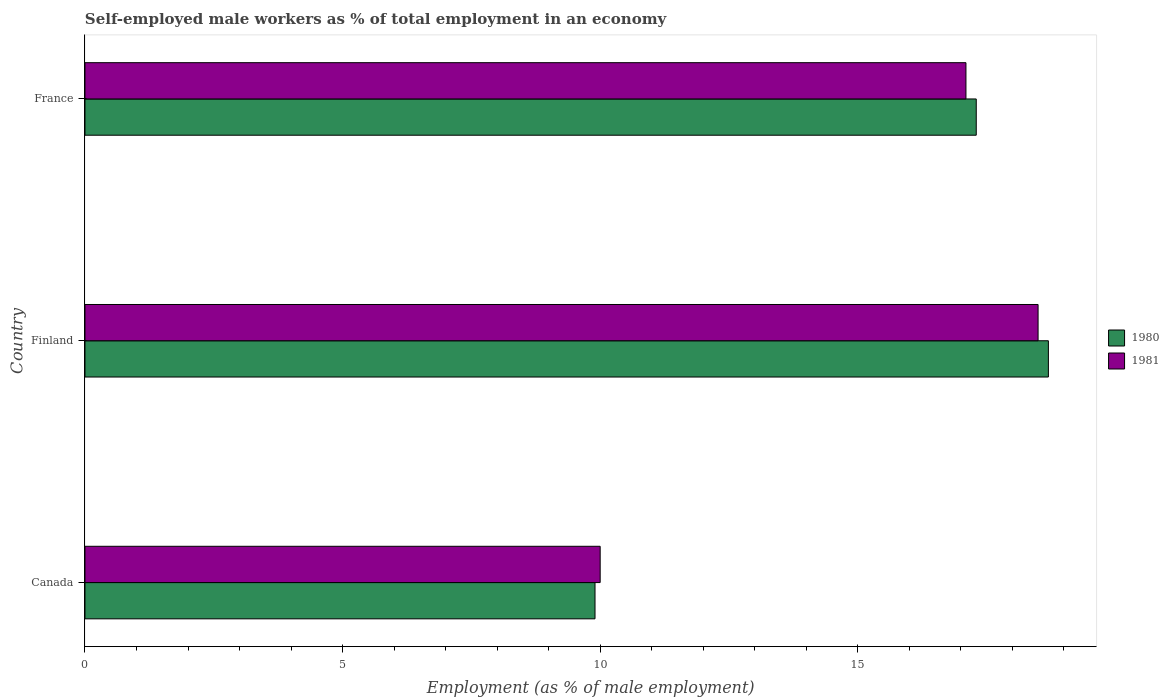Are the number of bars per tick equal to the number of legend labels?
Make the answer very short. Yes. How many bars are there on the 3rd tick from the top?
Keep it short and to the point. 2. What is the label of the 2nd group of bars from the top?
Your answer should be very brief. Finland. In how many cases, is the number of bars for a given country not equal to the number of legend labels?
Provide a short and direct response. 0. What is the percentage of self-employed male workers in 1981 in France?
Keep it short and to the point. 17.1. Across all countries, what is the minimum percentage of self-employed male workers in 1981?
Give a very brief answer. 10. In which country was the percentage of self-employed male workers in 1980 maximum?
Ensure brevity in your answer.  Finland. What is the total percentage of self-employed male workers in 1981 in the graph?
Keep it short and to the point. 45.6. What is the difference between the percentage of self-employed male workers in 1980 in Canada and that in France?
Offer a very short reply. -7.4. What is the difference between the percentage of self-employed male workers in 1980 in Canada and the percentage of self-employed male workers in 1981 in France?
Your response must be concise. -7.2. What is the average percentage of self-employed male workers in 1980 per country?
Make the answer very short. 15.3. What is the difference between the percentage of self-employed male workers in 1980 and percentage of self-employed male workers in 1981 in Finland?
Make the answer very short. 0.2. What is the ratio of the percentage of self-employed male workers in 1981 in Canada to that in Finland?
Your answer should be compact. 0.54. Is the difference between the percentage of self-employed male workers in 1980 in Finland and France greater than the difference between the percentage of self-employed male workers in 1981 in Finland and France?
Offer a very short reply. Yes. What is the difference between the highest and the second highest percentage of self-employed male workers in 1981?
Offer a terse response. 1.4. What is the difference between the highest and the lowest percentage of self-employed male workers in 1980?
Make the answer very short. 8.8. In how many countries, is the percentage of self-employed male workers in 1980 greater than the average percentage of self-employed male workers in 1980 taken over all countries?
Provide a short and direct response. 2. How many bars are there?
Offer a terse response. 6. How many countries are there in the graph?
Your response must be concise. 3. What is the difference between two consecutive major ticks on the X-axis?
Provide a succinct answer. 5. Are the values on the major ticks of X-axis written in scientific E-notation?
Ensure brevity in your answer.  No. Does the graph contain any zero values?
Your answer should be very brief. No. Does the graph contain grids?
Your answer should be compact. No. Where does the legend appear in the graph?
Your response must be concise. Center right. How are the legend labels stacked?
Provide a succinct answer. Vertical. What is the title of the graph?
Offer a terse response. Self-employed male workers as % of total employment in an economy. What is the label or title of the X-axis?
Keep it short and to the point. Employment (as % of male employment). What is the label or title of the Y-axis?
Offer a very short reply. Country. What is the Employment (as % of male employment) in 1980 in Canada?
Provide a succinct answer. 9.9. What is the Employment (as % of male employment) of 1980 in Finland?
Your answer should be very brief. 18.7. What is the Employment (as % of male employment) of 1981 in Finland?
Your response must be concise. 18.5. What is the Employment (as % of male employment) of 1980 in France?
Offer a terse response. 17.3. What is the Employment (as % of male employment) of 1981 in France?
Keep it short and to the point. 17.1. Across all countries, what is the maximum Employment (as % of male employment) of 1980?
Keep it short and to the point. 18.7. Across all countries, what is the minimum Employment (as % of male employment) of 1980?
Give a very brief answer. 9.9. What is the total Employment (as % of male employment) in 1980 in the graph?
Offer a very short reply. 45.9. What is the total Employment (as % of male employment) of 1981 in the graph?
Offer a terse response. 45.6. What is the difference between the Employment (as % of male employment) of 1980 in Canada and that in Finland?
Make the answer very short. -8.8. What is the difference between the Employment (as % of male employment) in 1981 in Canada and that in France?
Give a very brief answer. -7.1. What is the difference between the Employment (as % of male employment) in 1981 in Finland and that in France?
Provide a succinct answer. 1.4. What is the difference between the Employment (as % of male employment) of 1980 in Canada and the Employment (as % of male employment) of 1981 in Finland?
Provide a short and direct response. -8.6. What is the difference between the Employment (as % of male employment) of 1980 in Canada and the Employment (as % of male employment) of 1981 in France?
Ensure brevity in your answer.  -7.2. What is the difference between the Employment (as % of male employment) of 1980 in Finland and the Employment (as % of male employment) of 1981 in France?
Your answer should be very brief. 1.6. What is the average Employment (as % of male employment) of 1981 per country?
Ensure brevity in your answer.  15.2. What is the difference between the Employment (as % of male employment) of 1980 and Employment (as % of male employment) of 1981 in Canada?
Your response must be concise. -0.1. What is the difference between the Employment (as % of male employment) of 1980 and Employment (as % of male employment) of 1981 in France?
Your answer should be compact. 0.2. What is the ratio of the Employment (as % of male employment) of 1980 in Canada to that in Finland?
Make the answer very short. 0.53. What is the ratio of the Employment (as % of male employment) in 1981 in Canada to that in Finland?
Your response must be concise. 0.54. What is the ratio of the Employment (as % of male employment) in 1980 in Canada to that in France?
Your answer should be compact. 0.57. What is the ratio of the Employment (as % of male employment) of 1981 in Canada to that in France?
Provide a succinct answer. 0.58. What is the ratio of the Employment (as % of male employment) in 1980 in Finland to that in France?
Ensure brevity in your answer.  1.08. What is the ratio of the Employment (as % of male employment) in 1981 in Finland to that in France?
Your answer should be compact. 1.08. What is the difference between the highest and the second highest Employment (as % of male employment) in 1980?
Give a very brief answer. 1.4. What is the difference between the highest and the lowest Employment (as % of male employment) in 1981?
Provide a succinct answer. 8.5. 